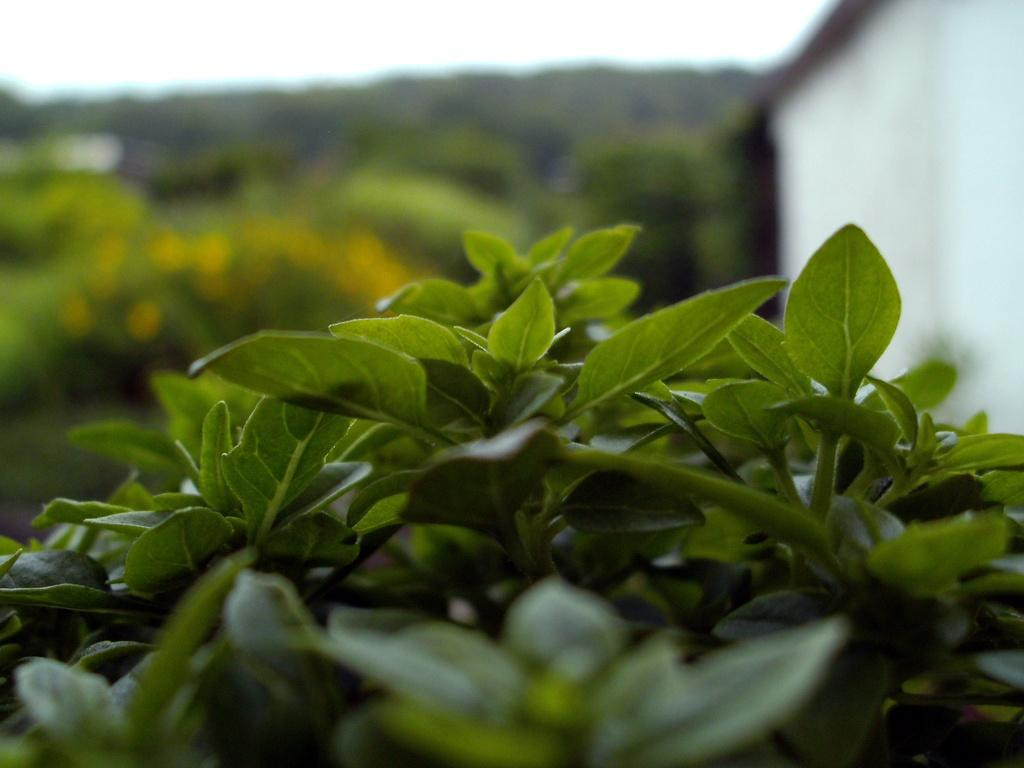What type of living organisms are present in the image? There are plants in the image. What color are the plants in the image? The plants are green in color. Can you describe the background of the image? The background of the image is blurred. How many family members can be seen pulling the chin of the plant in the image? There are no family members or chins present in the image; it features plants with a blurred background. 